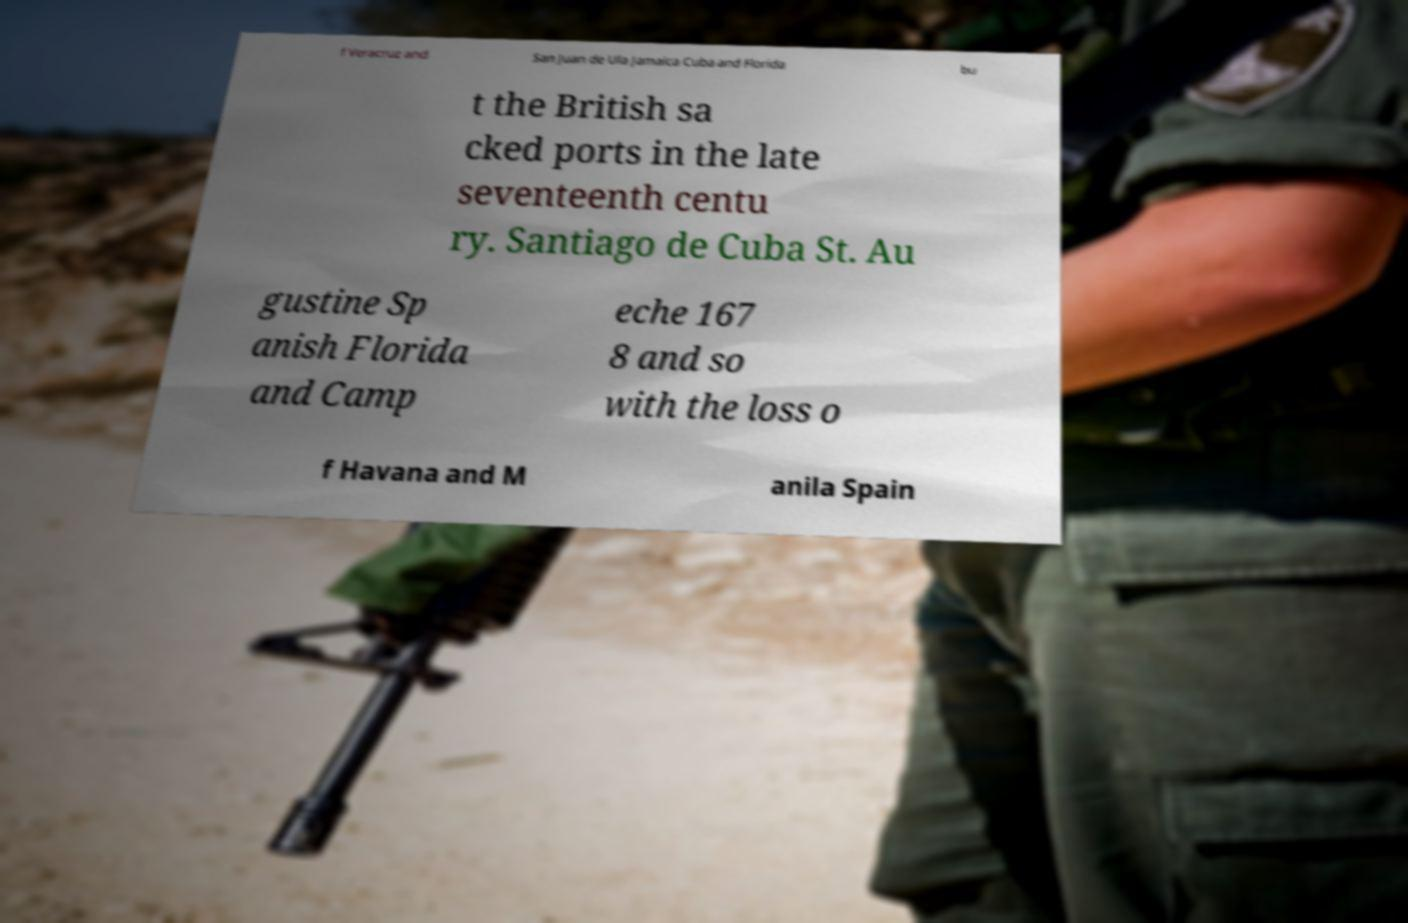I need the written content from this picture converted into text. Can you do that? f Veracruz and San Juan de Ula Jamaica Cuba and Florida bu t the British sa cked ports in the late seventeenth centu ry. Santiago de Cuba St. Au gustine Sp anish Florida and Camp eche 167 8 and so with the loss o f Havana and M anila Spain 